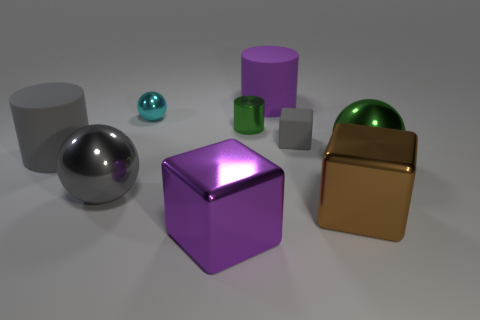How many objects are cyan spheres or brown metal things?
Give a very brief answer. 2. There is a big gray ball; are there any tiny rubber cubes to the left of it?
Your response must be concise. No. Is there another big thing that has the same material as the big green object?
Make the answer very short. Yes. The metal sphere that is the same color as the rubber cube is what size?
Provide a succinct answer. Large. How many cubes are large yellow metallic objects or big purple objects?
Keep it short and to the point. 1. Is the number of large metal spheres to the left of the small green cylinder greater than the number of large gray rubber objects that are right of the brown metal thing?
Your answer should be very brief. Yes. What number of shiny balls have the same color as the metal cylinder?
Keep it short and to the point. 1. The gray object that is made of the same material as the tiny cyan thing is what size?
Offer a very short reply. Large. How many things are small cyan spheres behind the big brown metal object or blocks?
Offer a terse response. 4. There is a large matte cylinder that is on the left side of the small cyan sphere; is its color the same as the small block?
Give a very brief answer. Yes. 